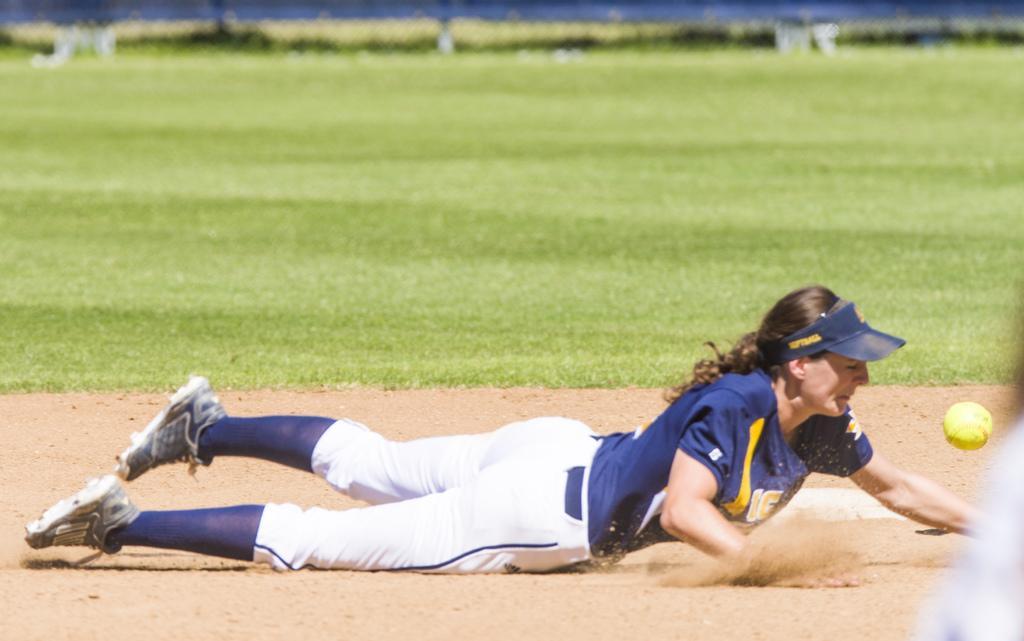In one or two sentences, can you explain what this image depicts? In this image there is a person laying on the ground, there is a ball, and in the background there is grass. 